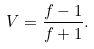Convert formula to latex. <formula><loc_0><loc_0><loc_500><loc_500>V = \frac { f - 1 } { f + 1 } .</formula> 